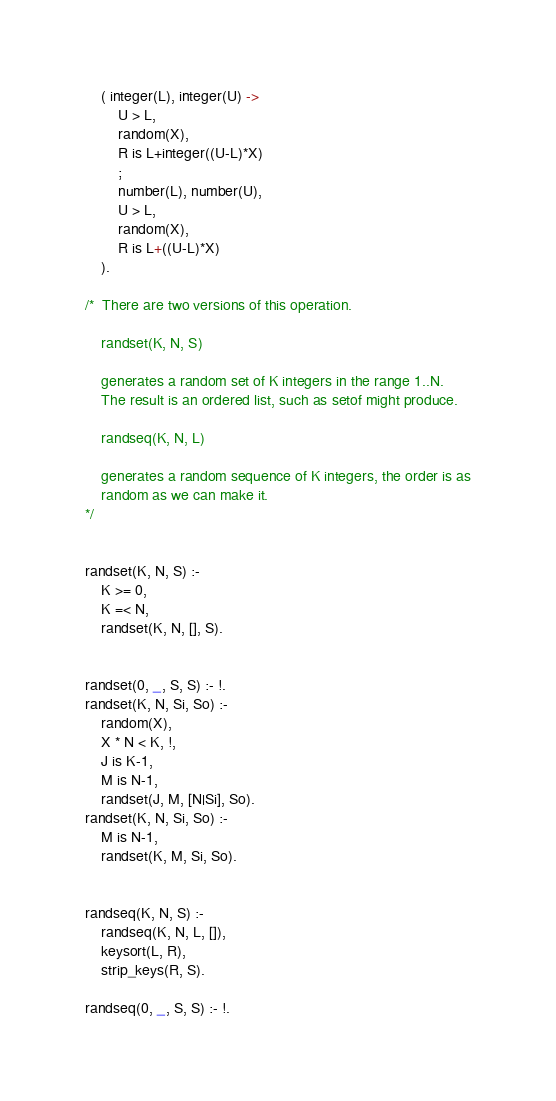<code> <loc_0><loc_0><loc_500><loc_500><_Prolog_>	( integer(L), integer(U) ->
	    U > L,
	    random(X),
	    R is L+integer((U-L)*X)
        ;
	    number(L), number(U),
	    U > L,
	    random(X),
	    R is L+((U-L)*X)
	).

/*  There are two versions of this operation.

	randset(K, N, S)

    generates a random set of K integers in the range 1..N.
    The result is an ordered list, such as setof might produce.

	randseq(K, N, L)

    generates a random sequence of K integers, the order is as
    random as we can make it.
*/


randset(K, N, S) :-
	K >= 0,
	K =< N,
	randset(K, N, [], S).


randset(0, _, S, S) :- !.
randset(K, N, Si, So) :-
	random(X),
	X * N < K, !,
	J is K-1,
	M is N-1,
	randset(J, M, [N|Si], So).
randset(K, N, Si, So) :-
	M is N-1,
	randset(K, M, Si, So).


randseq(K, N, S) :-
	randseq(K, N, L, []),
	keysort(L, R),
	strip_keys(R, S).

randseq(0, _, S, S) :- !.</code> 